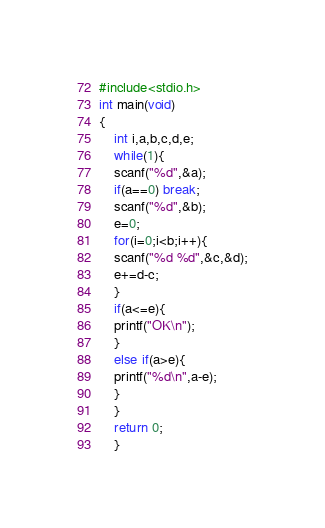<code> <loc_0><loc_0><loc_500><loc_500><_C++_>#include<stdio.h>
int main(void)
{
    int i,a,b,c,d,e;
	while(1){
	scanf("%d",&a);
	if(a==0) break;
	scanf("%d",&b);
	e=0;
	for(i=0;i<b;i++){
	scanf("%d %d",&c,&d);
	e+=d-c;
	}
	if(a<=e){
	printf("OK\n");
	}
	else if(a>e){
	printf("%d\n",a-e);
	}
	}
	return 0;
	}</code> 